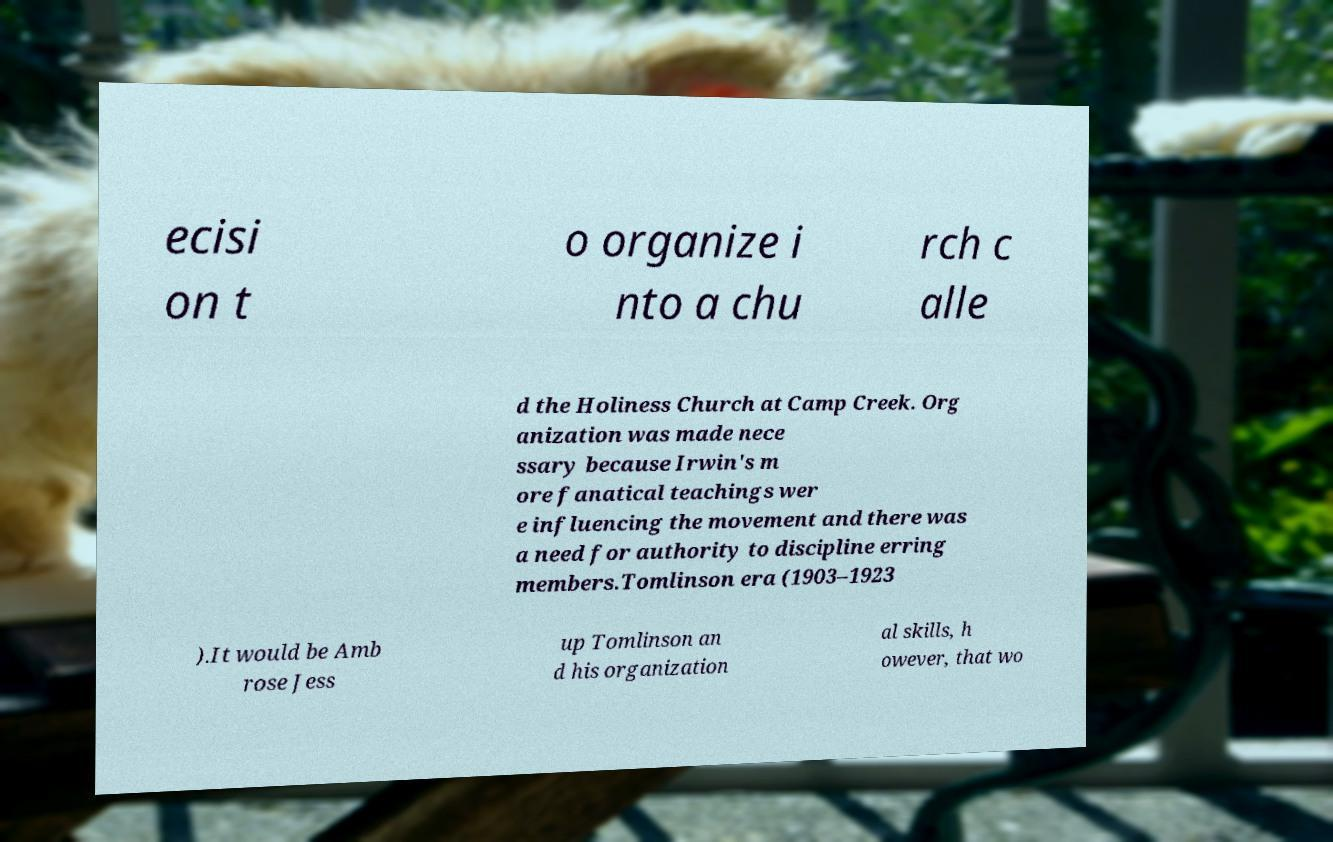What messages or text are displayed in this image? I need them in a readable, typed format. ecisi on t o organize i nto a chu rch c alle d the Holiness Church at Camp Creek. Org anization was made nece ssary because Irwin's m ore fanatical teachings wer e influencing the movement and there was a need for authority to discipline erring members.Tomlinson era (1903–1923 ).It would be Amb rose Jess up Tomlinson an d his organization al skills, h owever, that wo 